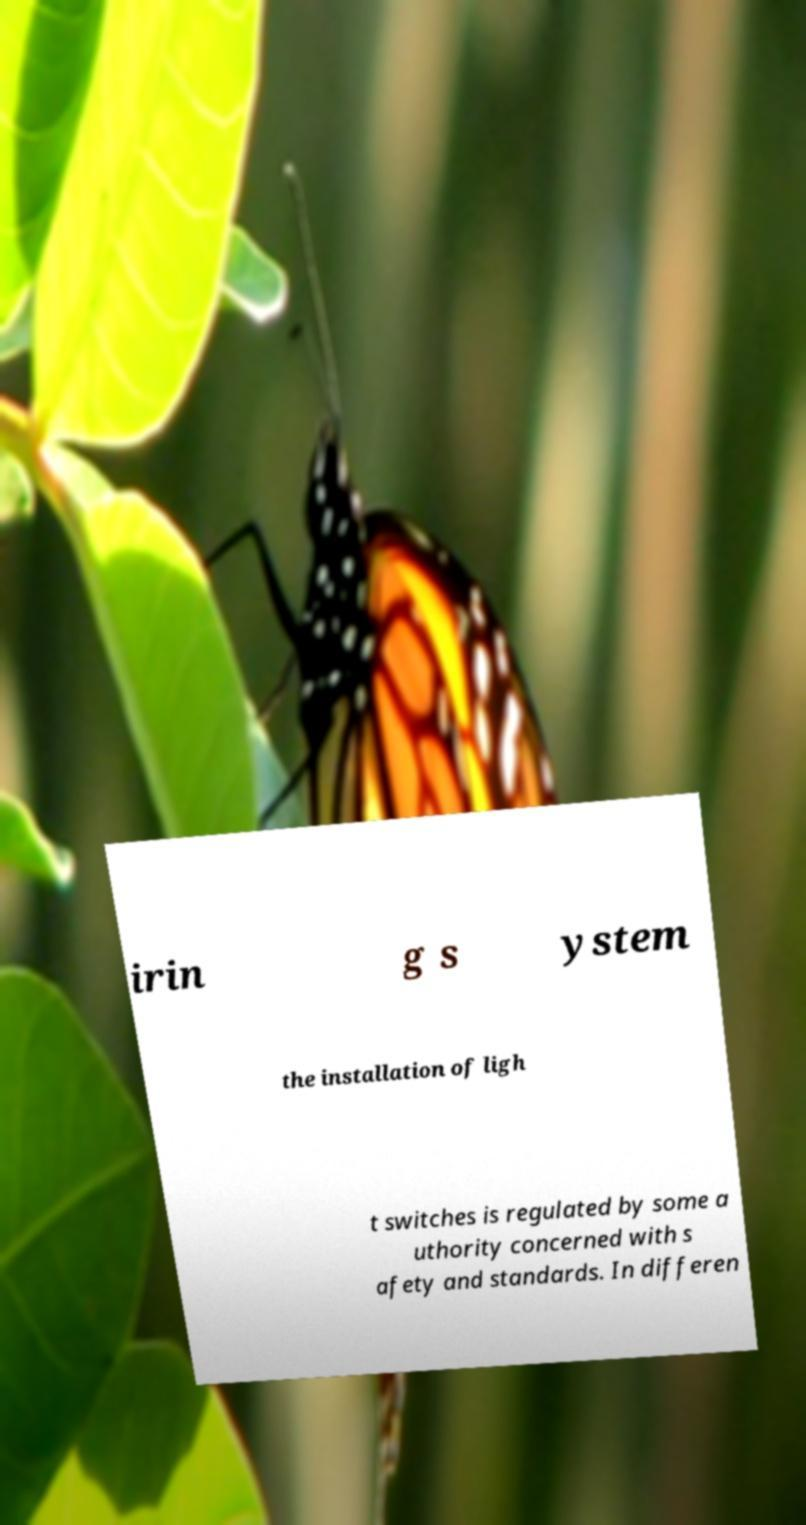Please identify and transcribe the text found in this image. irin g s ystem the installation of ligh t switches is regulated by some a uthority concerned with s afety and standards. In differen 